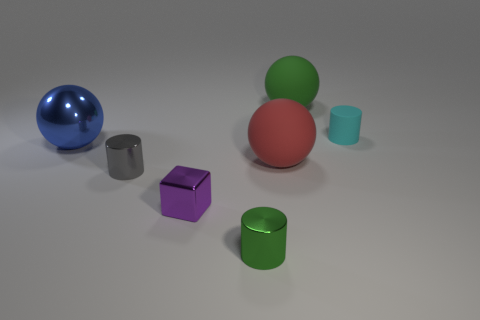Is the color of the tiny metallic block the same as the big rubber object behind the large metallic object?
Your answer should be compact. No. Are there more big blue shiny objects than big cyan rubber balls?
Your answer should be compact. Yes. The other metallic thing that is the same shape as the small gray object is what size?
Provide a short and direct response. Small. Is the material of the small gray cylinder the same as the tiny cylinder that is behind the blue metallic object?
Offer a very short reply. No. How many objects are either brown shiny cubes or purple shiny objects?
Ensure brevity in your answer.  1. Does the metallic cylinder that is to the right of the small gray shiny cylinder have the same size as the thing behind the small cyan matte cylinder?
Provide a succinct answer. No. How many cubes are either purple objects or green objects?
Offer a very short reply. 1. Is there a tiny purple shiny cube?
Provide a short and direct response. Yes. Is there any other thing that has the same shape as the small purple metal thing?
Your answer should be very brief. No. Is the tiny block the same color as the large shiny sphere?
Make the answer very short. No. 